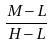<formula> <loc_0><loc_0><loc_500><loc_500>\frac { M - L } { H - L }</formula> 